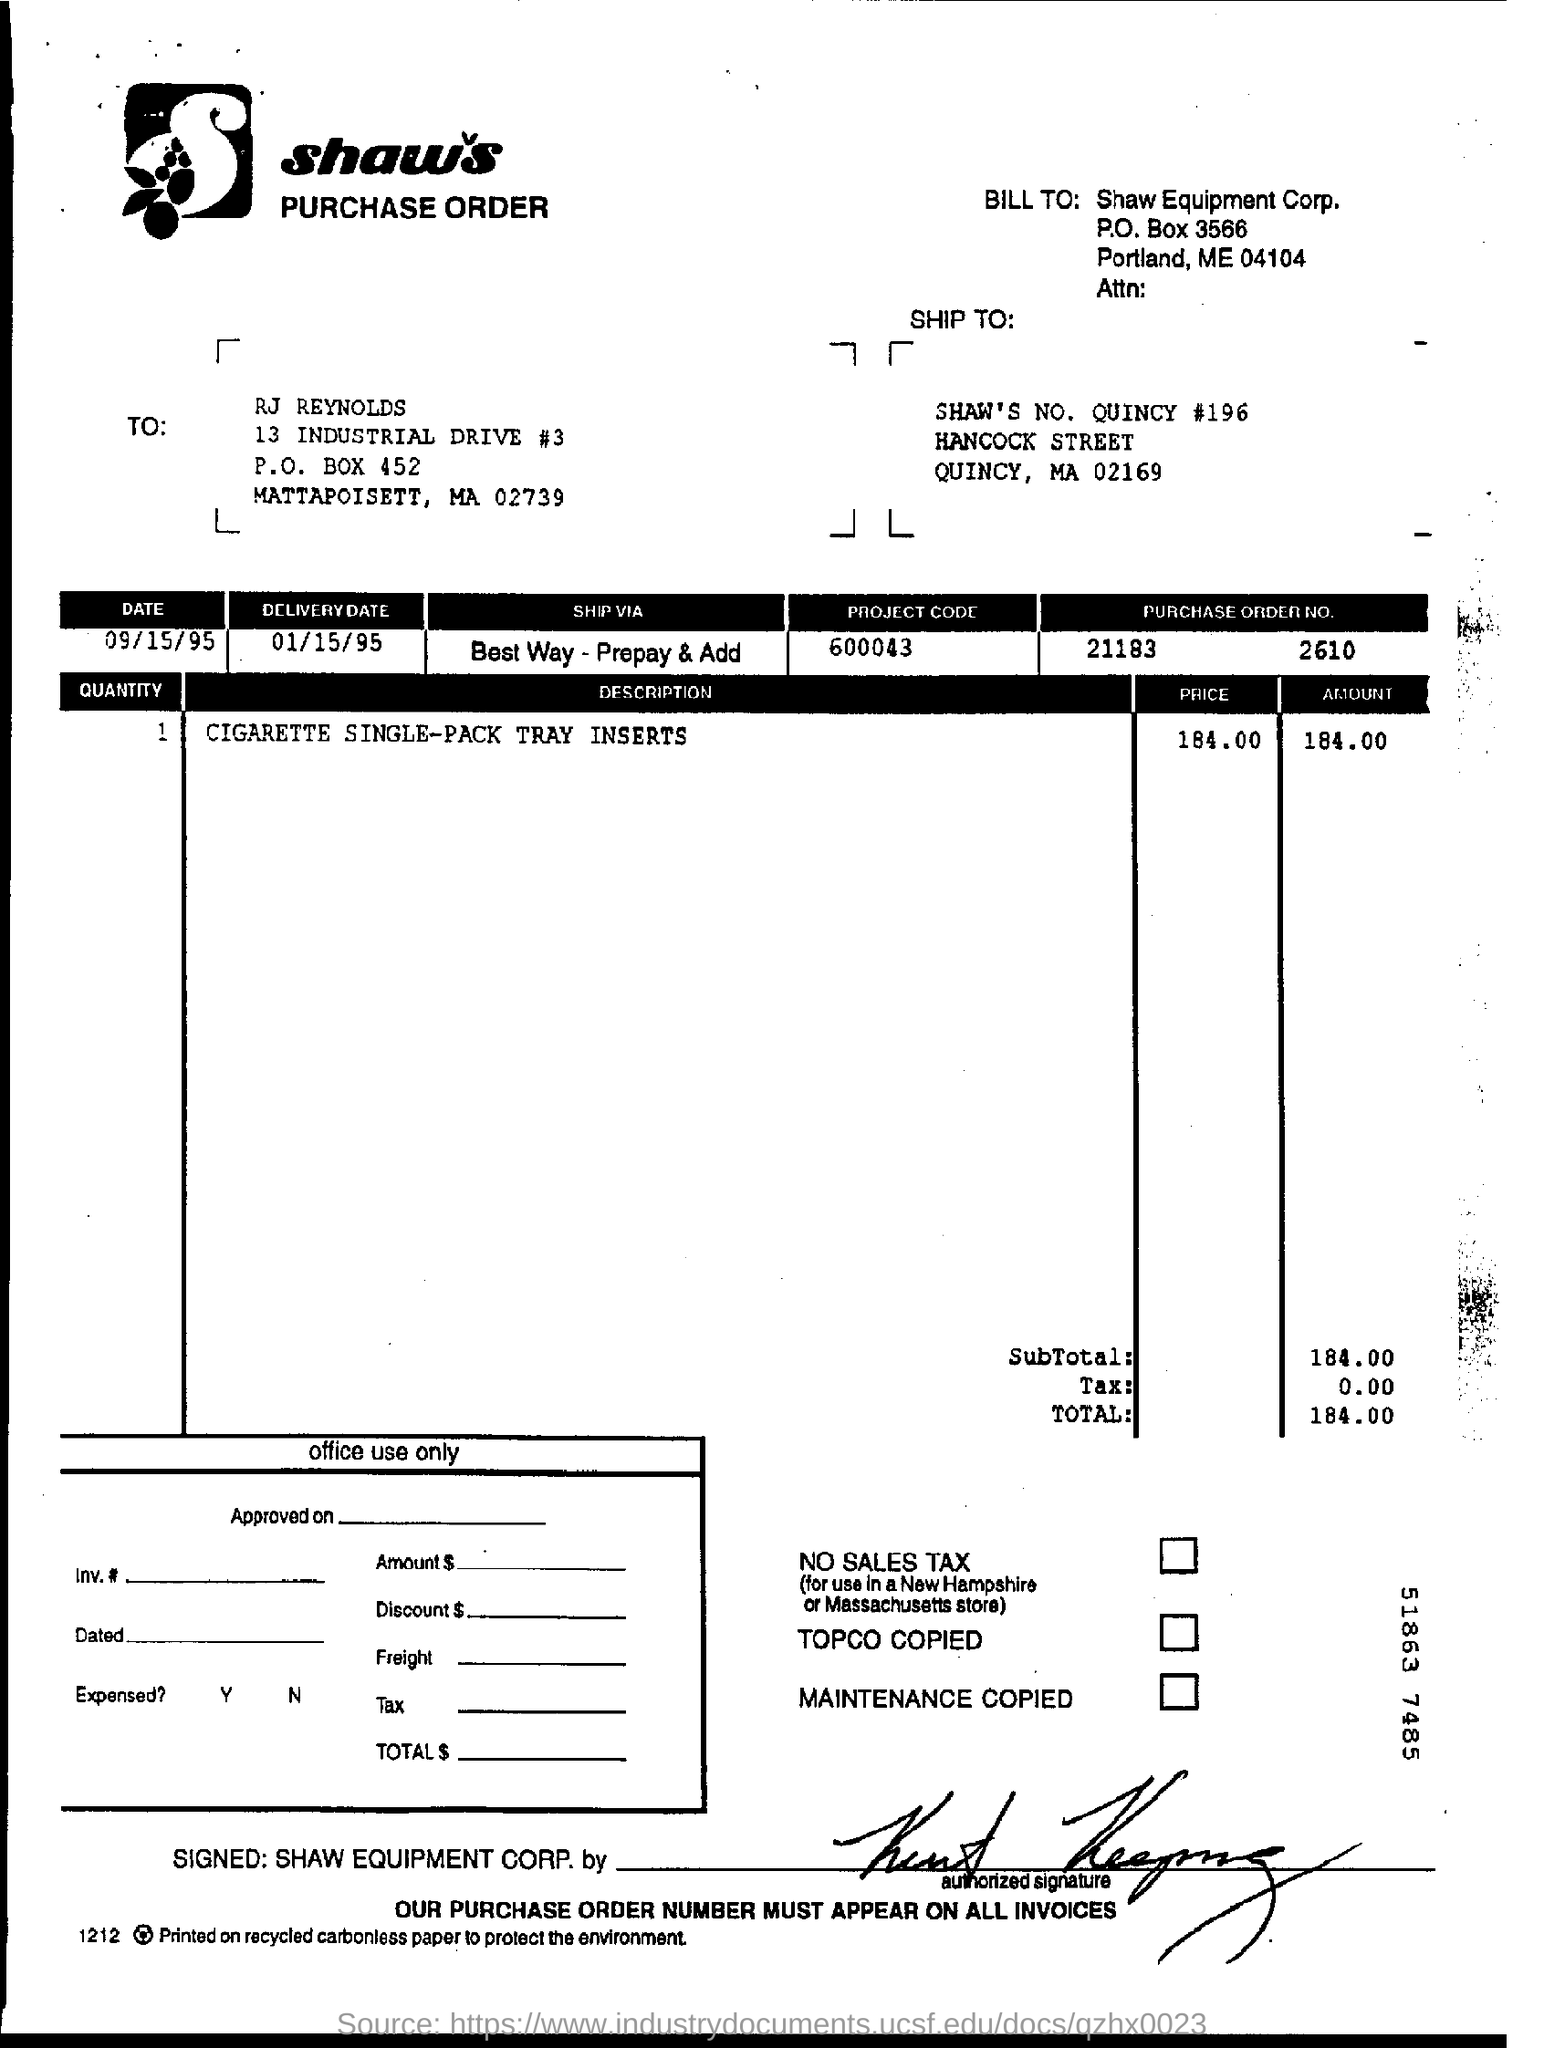Draw attention to some important aspects in this diagram. The delivery date is January 15, 1995. What is the purchase order number? 211832610... What is the project code? 600043... The P.O box number is 3566. 